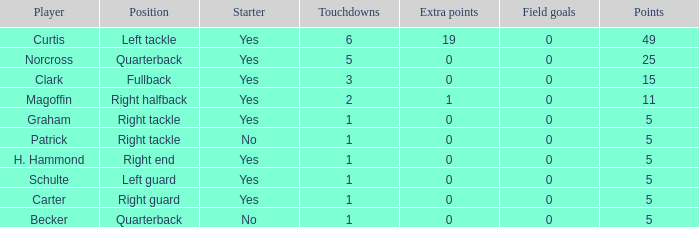Name the number of field goals for 19 extra points 1.0. 